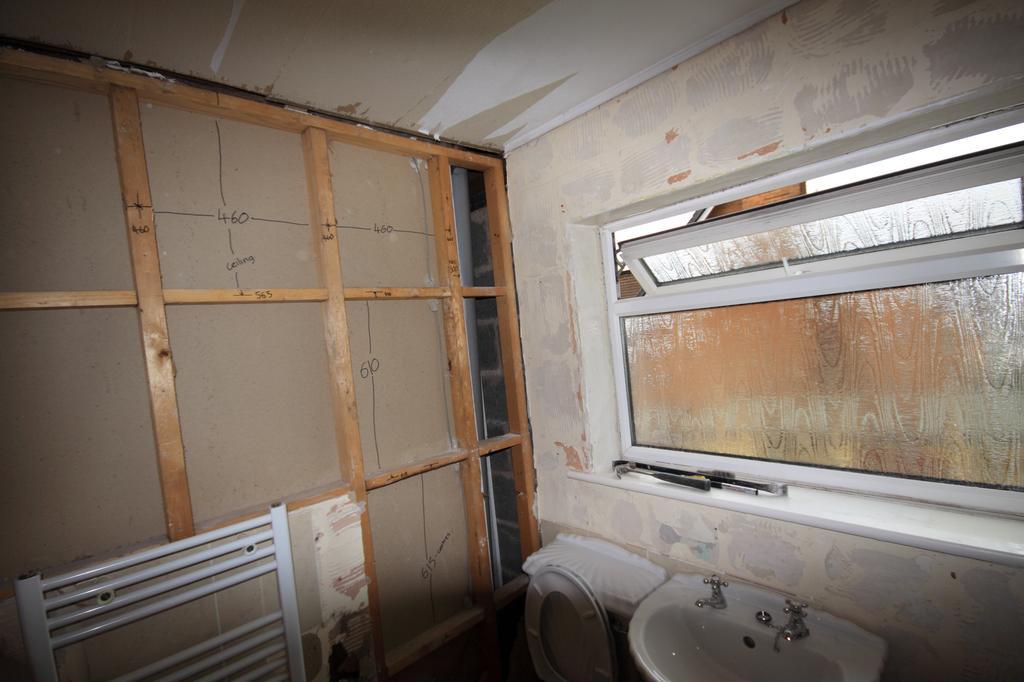Please provide a concise description of this image. In this image we can see a flush toilet, beside the flush toilet there is a sink with two taps on it, above the sink there is a glass window. 